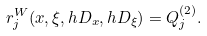Convert formula to latex. <formula><loc_0><loc_0><loc_500><loc_500>r _ { j } ^ { W } ( x , \xi , h D _ { x } , h D _ { \xi } ) = Q _ { j } ^ { ( 2 ) } .</formula> 